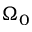<formula> <loc_0><loc_0><loc_500><loc_500>\Omega _ { 0 }</formula> 